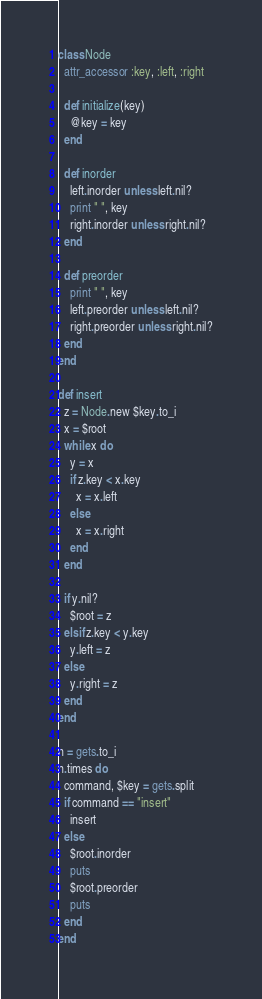<code> <loc_0><loc_0><loc_500><loc_500><_Ruby_>class Node
  attr_accessor :key, :left, :right

  def initialize(key)
    @key = key
  end

  def inorder
    left.inorder unless left.nil?
    print " ", key
    right.inorder unless right.nil?
  end

  def preorder
    print " ", key
    left.preorder unless left.nil?
    right.preorder unless right.nil?
  end
end

def insert
  z = Node.new $key.to_i
  x = $root
  while x do
    y = x
    if z.key < x.key
      x = x.left
    else 
      x = x.right
    end
  end
  
  if y.nil?
    $root = z
  elsif z.key < y.key
    y.left = z
  else
    y.right = z
  end
end

n = gets.to_i
n.times do
  command, $key = gets.split
  if command == "insert"
    insert
  else 
    $root.inorder
    puts
    $root.preorder
    puts
  end
end</code> 